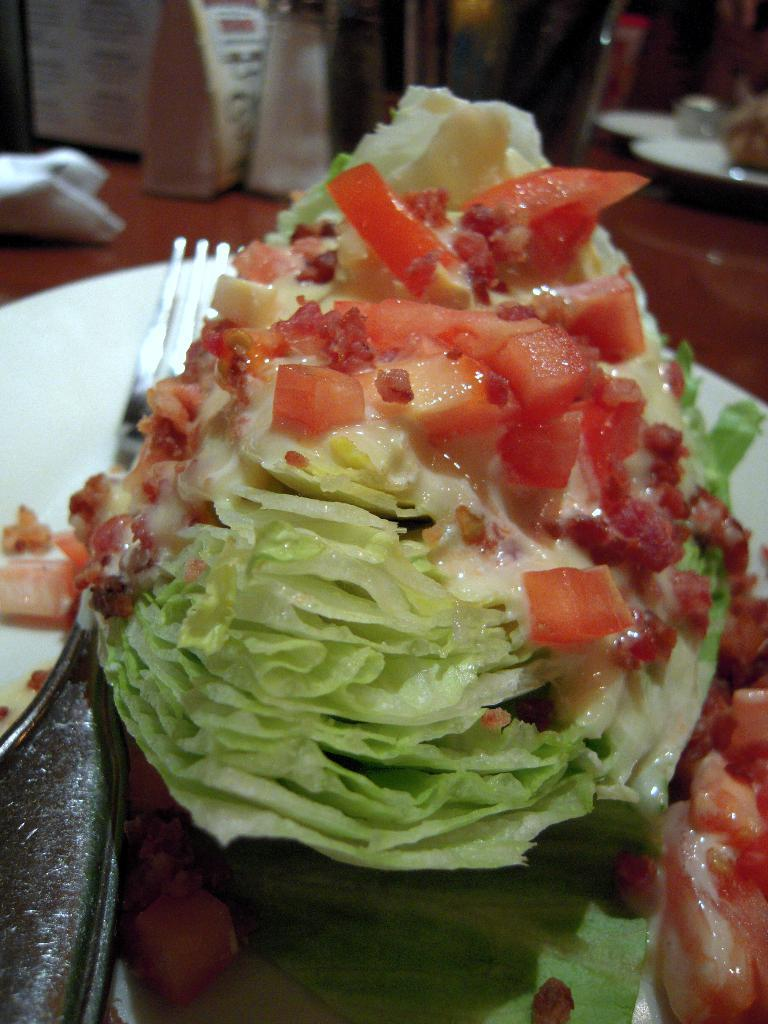What is the main object in the center of the image? There is a table in the center of the image. What items can be seen on the table? There are plates, banners, a fork, food items, and other objects on the table. What might be used for eating on the table? A fork is present on the table for eating. What type of items are on the table that might be related to a celebration or event? The banners on the table might be related to a celebration or event. Can you tell me how many feathers are on the table in the image? There is no mention of feathers in the image; they are not present. What type of fruit is the banana on the table in the image? There is no banana present in the image. 